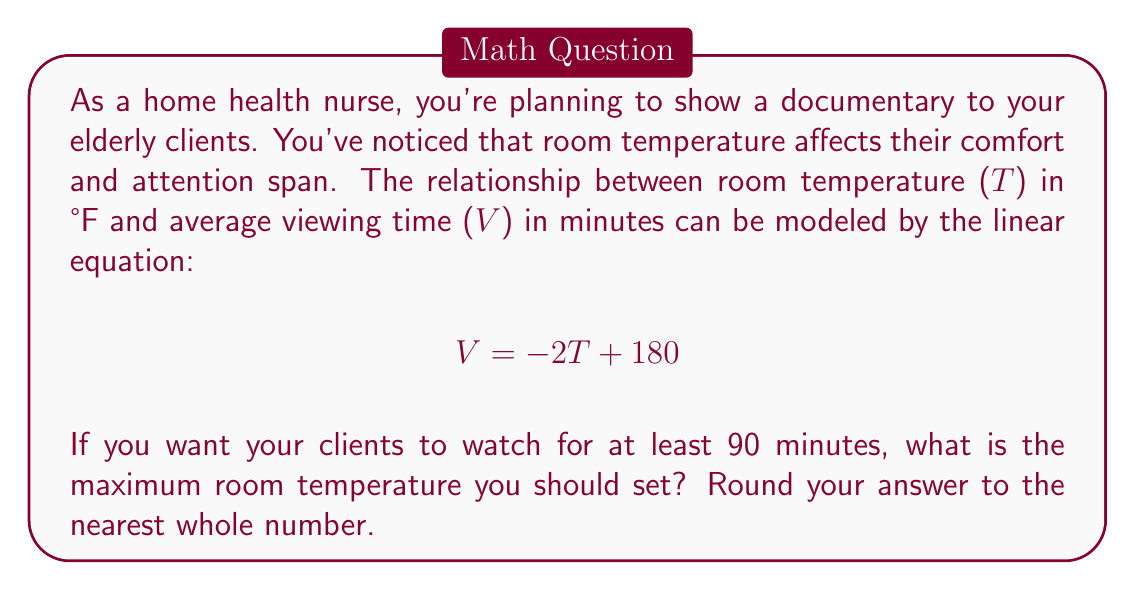Give your solution to this math problem. To solve this problem, we'll follow these steps:

1) We're given the linear equation: $V = -2T + 180$

2) We want to find the maximum temperature T when V is at least 90 minutes. This means we need to solve the inequality:

   $$ -2T + 180 \geq 90 $$

3) Subtract 180 from both sides:

   $$ -2T \geq -90 $$

4) Divide both sides by -2 (remember to flip the inequality sign when dividing by a negative number):

   $$ T \leq 45 $$

5) This means the temperature should be 45°F or lower to ensure at least 90 minutes of viewing time.

6) Since we're asked to round to the nearest whole number, and 45°F is already a whole number, our answer is 45°F.
Answer: 45°F 